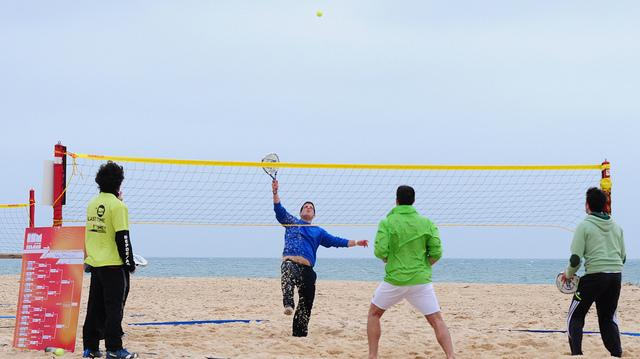What type of net is being played over? Please explain your reasoning. volleyball. We see the beach, the sand & the high nets. only one sport is played in this scenario. 